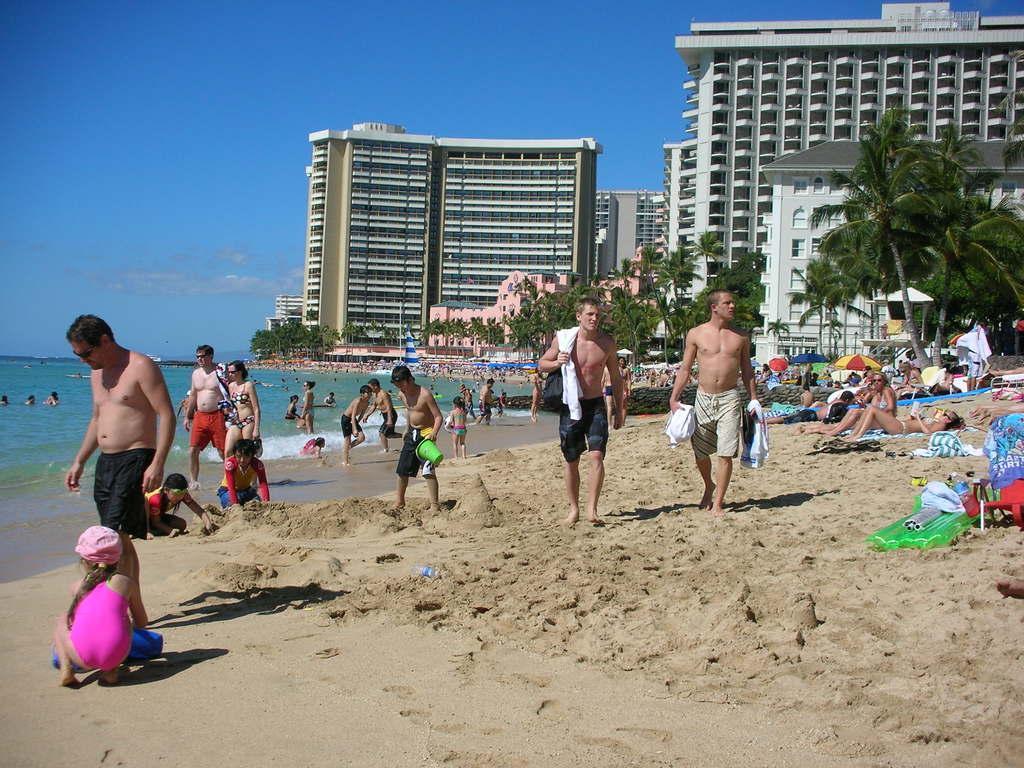Describe this image in one or two sentences. In the center of the image we can see a few people are walking, few people are lying, few people are sitting and a few people are holding some objects. And we can see they are in different costumes. And we can see blankets, outdoor umbrellas, relaxing chairs, one green color object and a few other objects. In the background, we can see the sky, clouds, trees, buildings, windows, water, one boat, few people are in the water and a few other objects. 